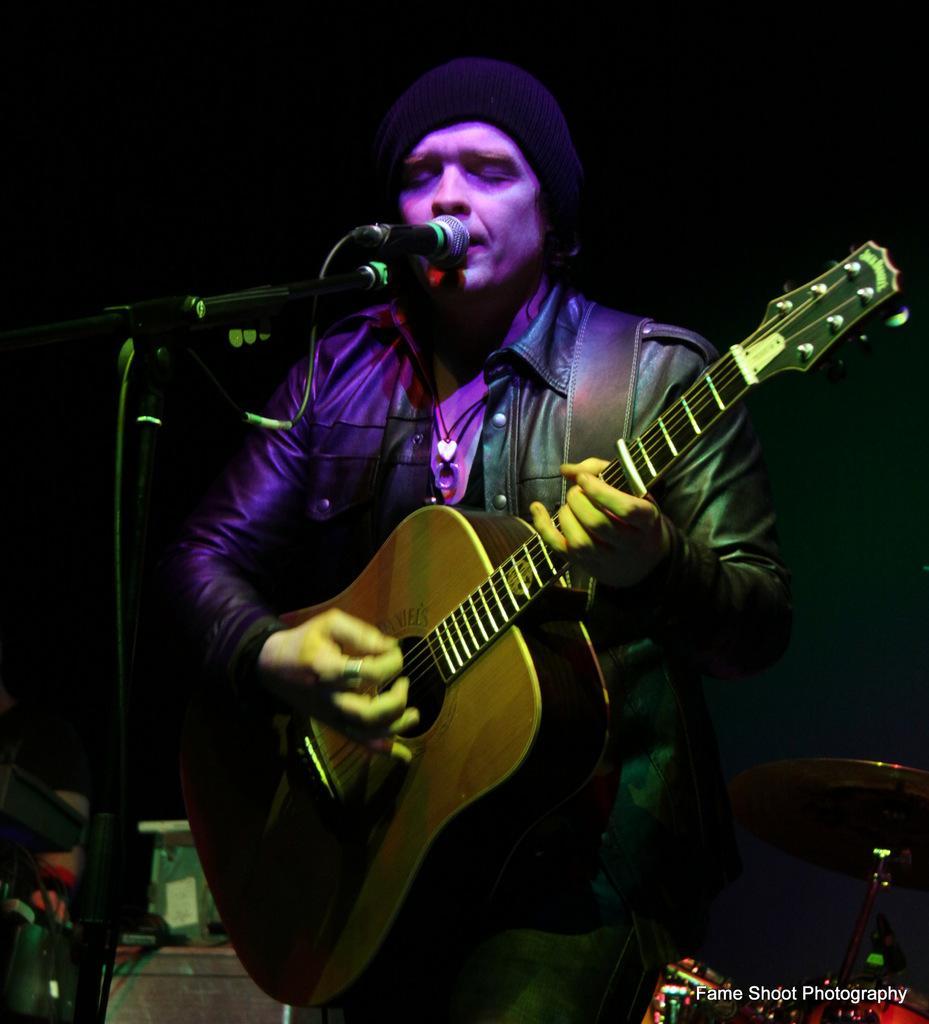How would you summarize this image in a sentence or two? In this picture when person is standing and he is playing a guitar with the help of microphone he is singing a song 